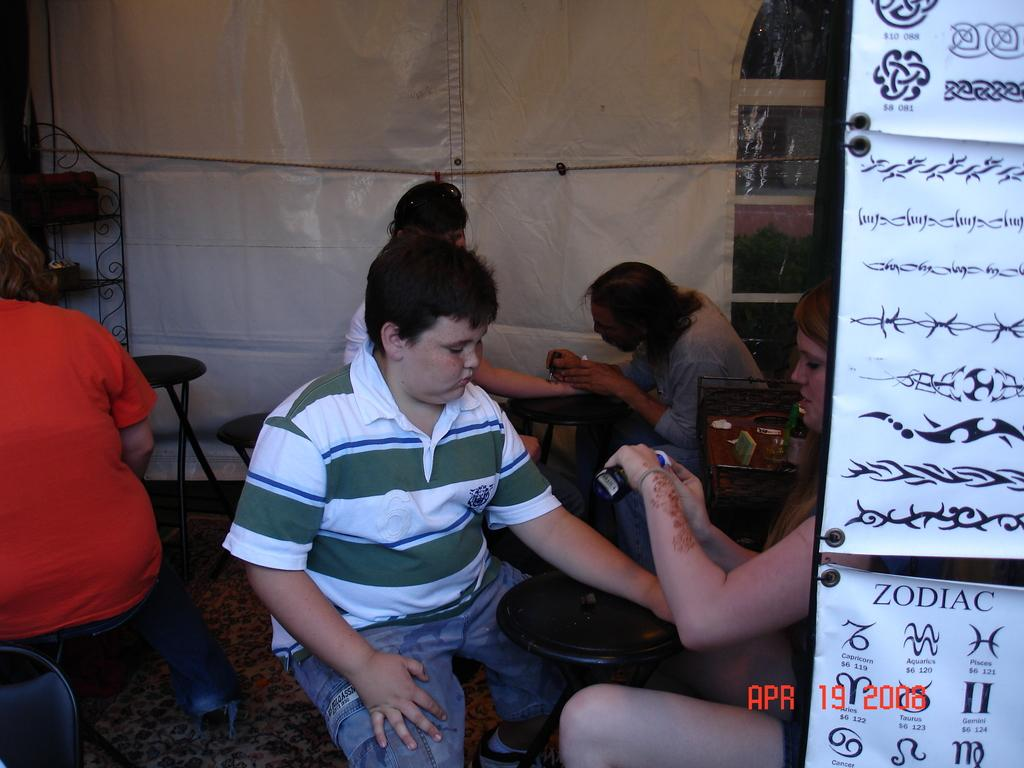How many people are in the image? There are two people in the image. What are the positions of the two people in relation to each other? The two people are sitting in opposite directions. What object is present between the two people? There is a stool in between the two people. What type of winter stocking can be seen on the head of one of the people in the image? There is no winter stocking or any type of stocking visible on the head of either person in the image. 